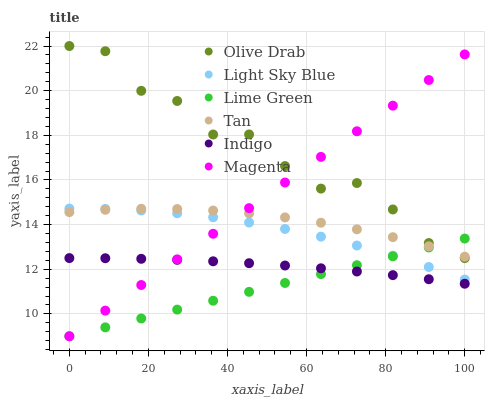Does Lime Green have the minimum area under the curve?
Answer yes or no. Yes. Does Olive Drab have the maximum area under the curve?
Answer yes or no. Yes. Does Light Sky Blue have the minimum area under the curve?
Answer yes or no. No. Does Light Sky Blue have the maximum area under the curve?
Answer yes or no. No. Is Lime Green the smoothest?
Answer yes or no. Yes. Is Olive Drab the roughest?
Answer yes or no. Yes. Is Light Sky Blue the smoothest?
Answer yes or no. No. Is Light Sky Blue the roughest?
Answer yes or no. No. Does Lime Green have the lowest value?
Answer yes or no. Yes. Does Light Sky Blue have the lowest value?
Answer yes or no. No. Does Olive Drab have the highest value?
Answer yes or no. Yes. Does Light Sky Blue have the highest value?
Answer yes or no. No. Is Indigo less than Olive Drab?
Answer yes or no. Yes. Is Light Sky Blue greater than Indigo?
Answer yes or no. Yes. Does Magenta intersect Tan?
Answer yes or no. Yes. Is Magenta less than Tan?
Answer yes or no. No. Is Magenta greater than Tan?
Answer yes or no. No. Does Indigo intersect Olive Drab?
Answer yes or no. No. 